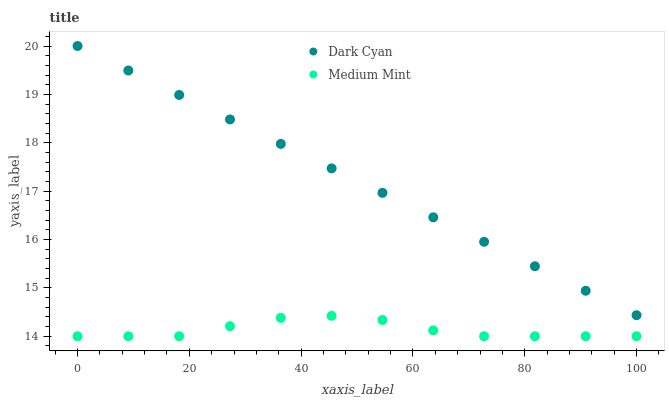Does Medium Mint have the minimum area under the curve?
Answer yes or no. Yes. Does Dark Cyan have the maximum area under the curve?
Answer yes or no. Yes. Does Medium Mint have the maximum area under the curve?
Answer yes or no. No. Is Dark Cyan the smoothest?
Answer yes or no. Yes. Is Medium Mint the roughest?
Answer yes or no. Yes. Is Medium Mint the smoothest?
Answer yes or no. No. Does Medium Mint have the lowest value?
Answer yes or no. Yes. Does Dark Cyan have the highest value?
Answer yes or no. Yes. Does Medium Mint have the highest value?
Answer yes or no. No. Is Medium Mint less than Dark Cyan?
Answer yes or no. Yes. Is Dark Cyan greater than Medium Mint?
Answer yes or no. Yes. Does Medium Mint intersect Dark Cyan?
Answer yes or no. No. 